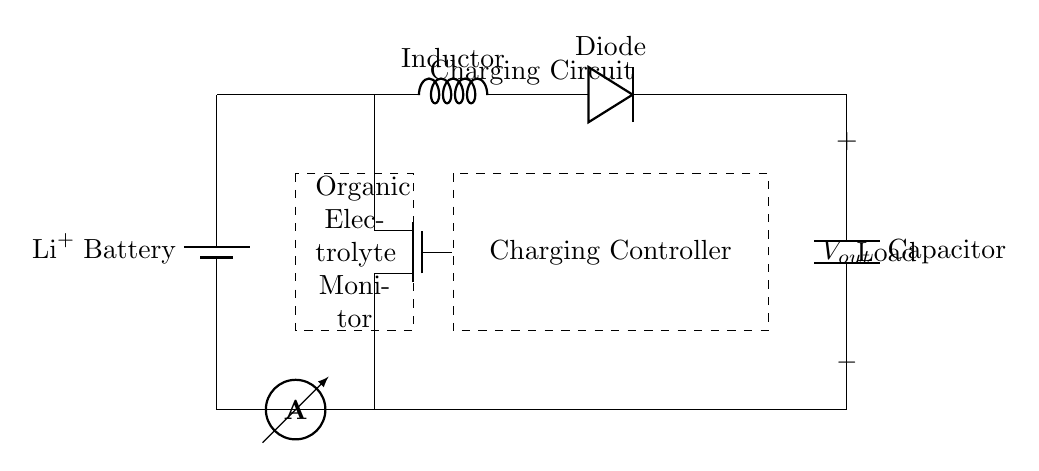What type of battery is used in this circuit? The circuit diagram explicitly labels the battery as a lithium-ion battery with the notation $\ch{Li+}$. This is shown at the left side of the circuit where the battery component is drawn.
Answer: lithium-ion What component regulates the charging process? The circuit includes a charging controller, which is indicated by the dashed rectangle labeled "Charging Controller." This component manages the charging of the battery, ensuring optimal charging conditions.
Answer: Charging Controller How is the organic electrolyte monitored? There is a component labeled as "Organic Electrolyte Monitor" enclosed in a dashed rectangle. This indicates that this part of the circuit is designated for monitoring the organic electrolyte condition within the battery.
Answer: Organic Electrolyte Monitor What is the purpose of the diode in this charging circuit? The diode is placed in the circuit to allow current to flow in one direction only, preventing backflow and protecting the battery from potential damage. This function is crucial in a charging circuit to maintain proper charging flow.
Answer: Prevent backflow How does current flow within this circuit? Current flows from the battery through the current sensor, into the charging controller, then through the MOSFET and other components, ultimately leading to the load. The indicated components facilitate the controlled flow of electric charge throughout the circuit, ensuring safe charging and operation.
Answer: From battery to load What type of sensor is used to monitor output voltage? The circuit specifies an open connection labeled $V_{out}$, indicating the use of a voltage sensor. This sensor measures the voltage output of the system to ensure it stays within the required limits during charging.
Answer: Voltage sensor What role does the inductor play in the circuit? The inductor, shown in series with the charging circuit, is used to smooth out current variations and help manage the charging process. Its presence buffers against sudden changes in current, contributing to stabilizing the overall charging cycle.
Answer: Smoothing current 